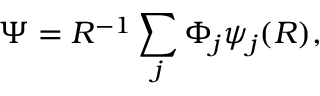Convert formula to latex. <formula><loc_0><loc_0><loc_500><loc_500>\Psi = R ^ { - 1 } \sum _ { j } \Phi _ { j } \psi _ { j } ( R ) ,</formula> 